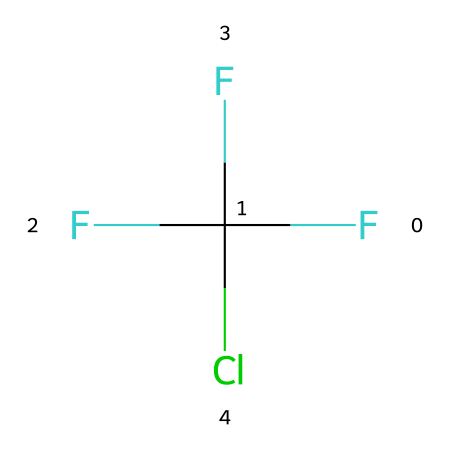What is the molecular formula of this compound? The SMILES representation FC(F)(F)Cl indicates the presence of one carbon atom (C), four fluorine atoms (F), and one chlorine atom (Cl). Therefore, the molecular formula can be deduced as CClF3.
Answer: CClF3 How many atoms are in this molecule? The molecule consists of one carbon atom, four fluorine atoms, and one chlorine atom. Adding these together gives a total of six atoms in the molecule.
Answer: 6 What type of halogen is present in the structure? The presence of the chlorine atom (Cl) in the SMILES representation indicates that chlorine is a halogen.
Answer: chlorine What is the total number of fluorine atoms in this compound? In the SMILES representation, three F symbols represent the three fluorine atoms. Therefore, the total number of fluorine atoms in this compound is counted directly as three.
Answer: 3 Is this compound classified as an ozone-depleting substance? Chlorofluorocarbons (CFCs), including this compound, are known for depleting the ozone layer due to the release of chlorine atoms when they break down in the atmosphere.
Answer: yes What characteristic of this compound leads to its use in refrigeration and aerosol propellants? The presence of multiple fluorine atoms contributes to its stability and low toxicity, making it effective in refrigeration and aerosol propellants while being non-flammable.
Answer: stability 